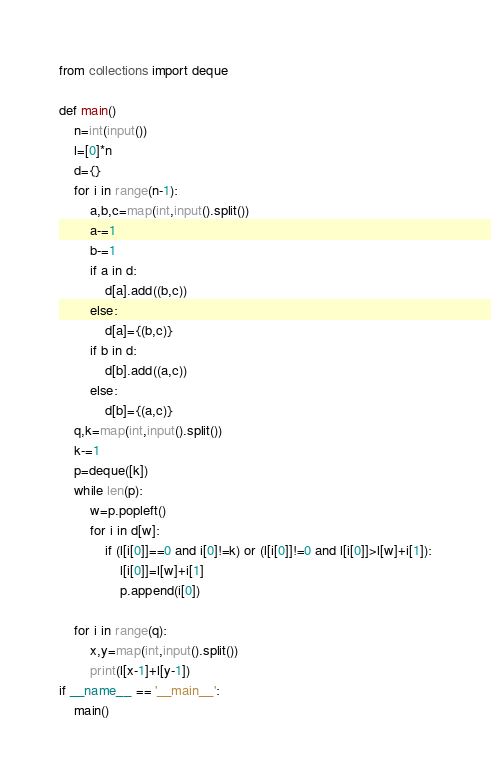<code> <loc_0><loc_0><loc_500><loc_500><_Python_>from collections import deque

def main()
    n=int(input())
    l=[0]*n
    d={}
    for i in range(n-1):
        a,b,c=map(int,input().split())
        a-=1
        b-=1
        if a in d:
            d[a].add((b,c))
        else:
            d[a]={(b,c)}
        if b in d:
            d[b].add((a,c))
        else:
            d[b]={(a,c)}
    q,k=map(int,input().split())
    k-=1
    p=deque([k])
    while len(p):
        w=p.popleft()
        for i in d[w]:
            if (l[i[0]]==0 and i[0]!=k) or (l[i[0]]!=0 and l[i[0]]>l[w]+i[1]):
                l[i[0]]=l[w]+i[1]
                p.append(i[0])

    for i in range(q):
        x,y=map(int,input().split())
        print(l[x-1]+l[y-1])
if __name__ == '__main__':
    main()
</code> 